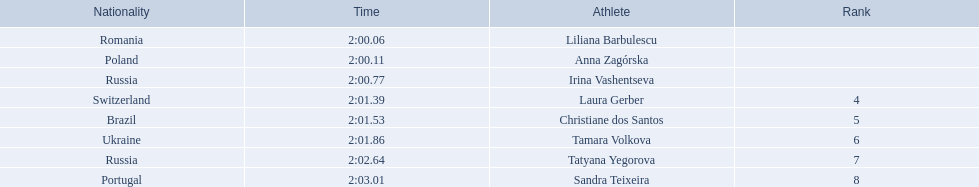Which athletes competed in the 2003 summer universiade - women's 800 metres? Liliana Barbulescu, Anna Zagórska, Irina Vashentseva, Laura Gerber, Christiane dos Santos, Tamara Volkova, Tatyana Yegorova, Sandra Teixeira. Of these, which are from poland? Anna Zagórska. What is her time? 2:00.11. 